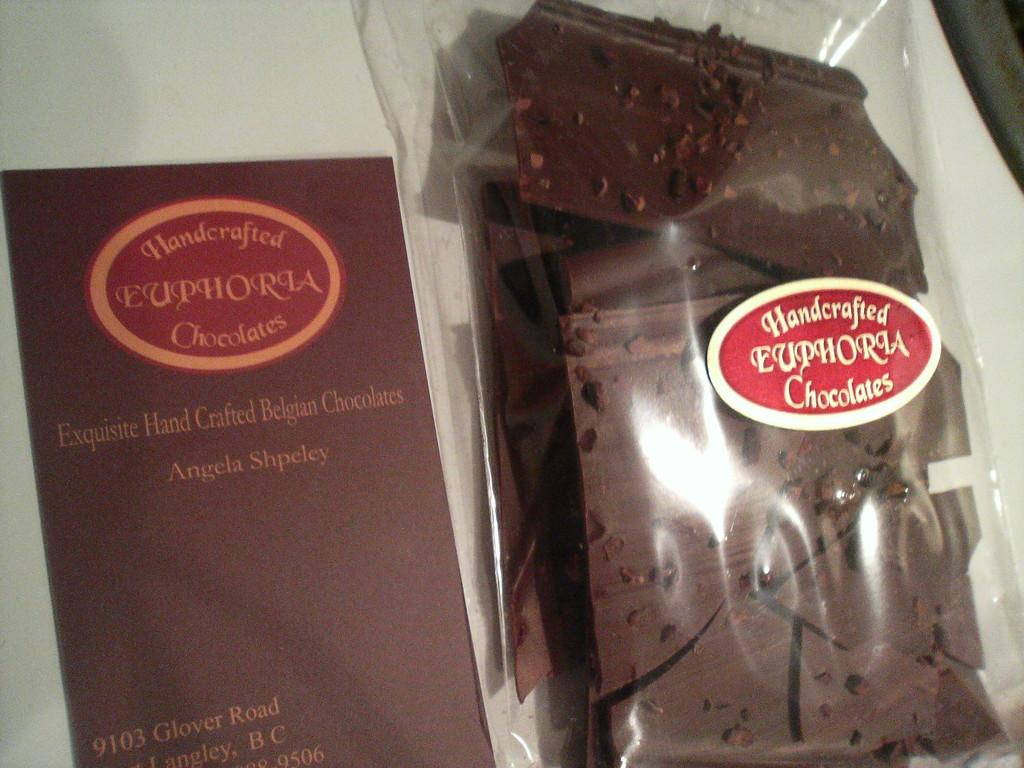What is present in the image that can be written on or read from? There is a paper in the image that can be written on or read from. What type of food is visible in the image? There are chocolates in the image. How are the chocolates contained in the image? The chocolates are in a cover. What additional decoration or information is present on the cover? There is a sticker on the cover. How many legs can be seen on the chocolates in the image? Chocolates do not have legs, so this question cannot be answered based on the image. 